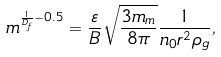<formula> <loc_0><loc_0><loc_500><loc_500>m ^ { \frac { 1 } { D _ { f } } - 0 . 5 } = \frac { \varepsilon } { B } \sqrt { \frac { 3 m _ { m } } { 8 \pi } } \frac { 1 } { n _ { 0 } r ^ { 2 } \rho _ { g } } ,</formula> 